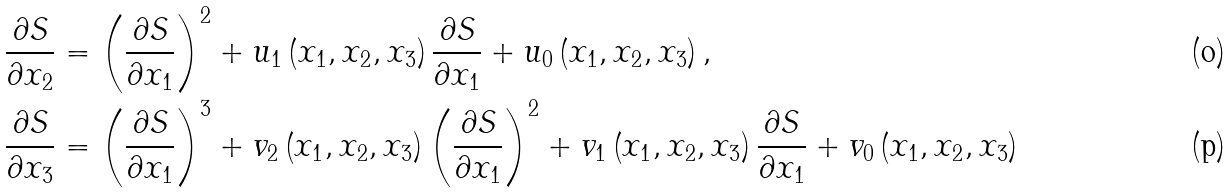<formula> <loc_0><loc_0><loc_500><loc_500>\frac { \partial S } { \partial x _ { 2 } } & = \left ( \frac { \partial S } { \partial x _ { 1 } } \right ) ^ { 2 } + u _ { 1 } \left ( x _ { 1 } , x _ { 2 } , x _ { 3 } \right ) \frac { \partial S } { \partial x _ { 1 } } + u _ { 0 } \left ( x _ { 1 } , x _ { 2 } , x _ { 3 } \right ) , \\ \frac { \partial S } { \partial x _ { 3 } } & = \left ( \frac { \partial S } { \partial x _ { 1 } } \right ) ^ { 3 } + v _ { 2 } \left ( x _ { 1 } , x _ { 2 } , x _ { 3 } \right ) \left ( \frac { \partial S } { \partial x _ { 1 } } \right ) ^ { 2 } + v _ { 1 } \left ( x _ { 1 } , x _ { 2 } , x _ { 3 } \right ) \frac { \partial S } { \partial x _ { 1 } } + v _ { 0 } \left ( x _ { 1 } , x _ { 2 } , x _ { 3 } \right )</formula> 